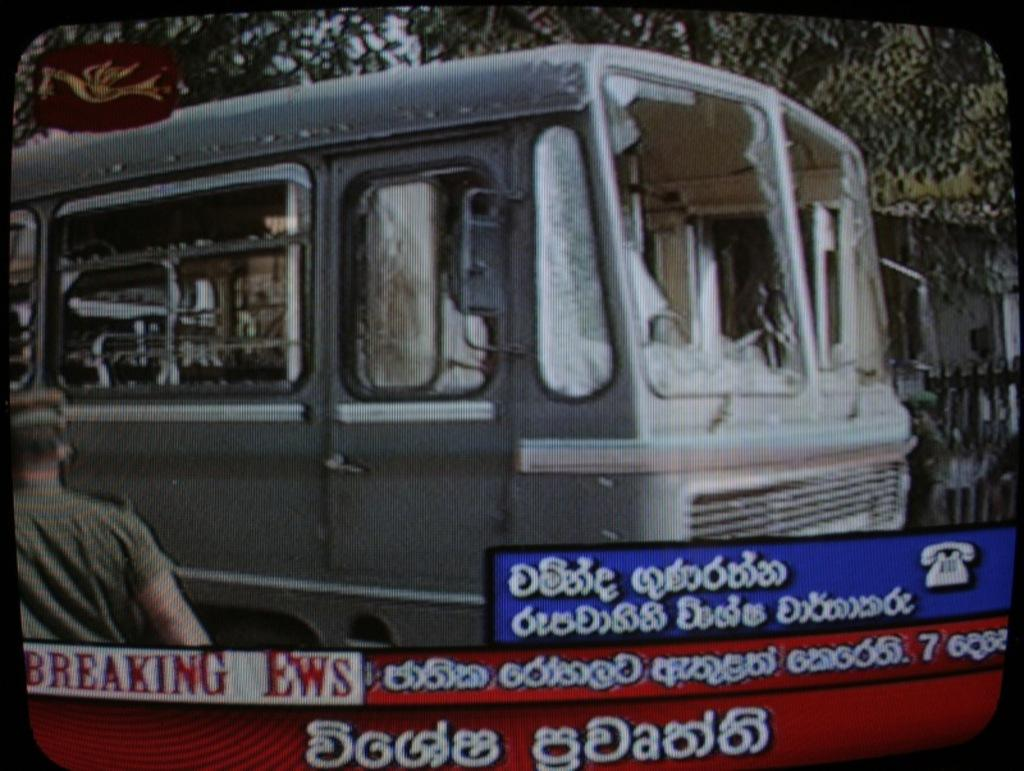What is the main object in the image? There is a screen in the image. What can be seen on the screen? A vehicle is visible on the screen, along with a person in the foreground. What additional information is provided on the screen? There is text at the bottom of the screen. What can be seen in the background of the image? There are trees in the background of the image. What is the condition of the gold in the image? There is no gold present in the image. Does the existence of the vehicle on the screen imply that the person is driving? The image does not provide enough information to determine whether the person is driving or not. 